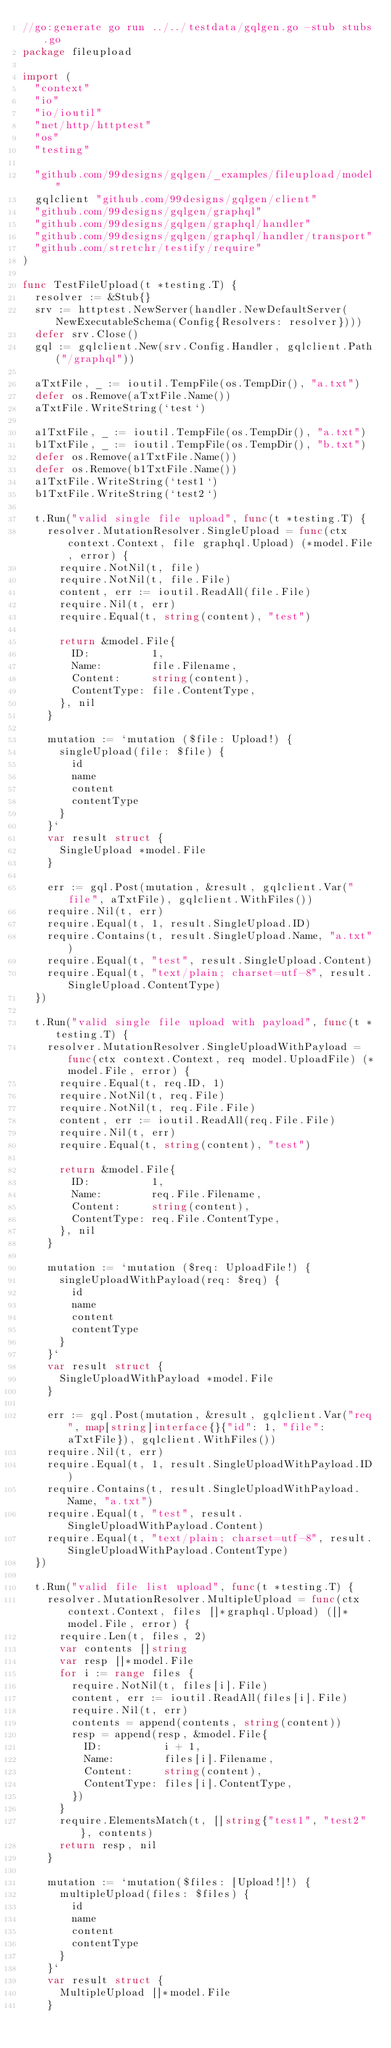<code> <loc_0><loc_0><loc_500><loc_500><_Go_>//go:generate go run ../../testdata/gqlgen.go -stub stubs.go
package fileupload

import (
	"context"
	"io"
	"io/ioutil"
	"net/http/httptest"
	"os"
	"testing"

	"github.com/99designs/gqlgen/_examples/fileupload/model"
	gqlclient "github.com/99designs/gqlgen/client"
	"github.com/99designs/gqlgen/graphql"
	"github.com/99designs/gqlgen/graphql/handler"
	"github.com/99designs/gqlgen/graphql/handler/transport"
	"github.com/stretchr/testify/require"
)

func TestFileUpload(t *testing.T) {
	resolver := &Stub{}
	srv := httptest.NewServer(handler.NewDefaultServer(NewExecutableSchema(Config{Resolvers: resolver})))
	defer srv.Close()
	gql := gqlclient.New(srv.Config.Handler, gqlclient.Path("/graphql"))

	aTxtFile, _ := ioutil.TempFile(os.TempDir(), "a.txt")
	defer os.Remove(aTxtFile.Name())
	aTxtFile.WriteString(`test`)

	a1TxtFile, _ := ioutil.TempFile(os.TempDir(), "a.txt")
	b1TxtFile, _ := ioutil.TempFile(os.TempDir(), "b.txt")
	defer os.Remove(a1TxtFile.Name())
	defer os.Remove(b1TxtFile.Name())
	a1TxtFile.WriteString(`test1`)
	b1TxtFile.WriteString(`test2`)

	t.Run("valid single file upload", func(t *testing.T) {
		resolver.MutationResolver.SingleUpload = func(ctx context.Context, file graphql.Upload) (*model.File, error) {
			require.NotNil(t, file)
			require.NotNil(t, file.File)
			content, err := ioutil.ReadAll(file.File)
			require.Nil(t, err)
			require.Equal(t, string(content), "test")

			return &model.File{
				ID:          1,
				Name:        file.Filename,
				Content:     string(content),
				ContentType: file.ContentType,
			}, nil
		}

		mutation := `mutation ($file: Upload!) {
			singleUpload(file: $file) {
				id
				name
				content
				contentType
			}
		}`
		var result struct {
			SingleUpload *model.File
		}

		err := gql.Post(mutation, &result, gqlclient.Var("file", aTxtFile), gqlclient.WithFiles())
		require.Nil(t, err)
		require.Equal(t, 1, result.SingleUpload.ID)
		require.Contains(t, result.SingleUpload.Name, "a.txt")
		require.Equal(t, "test", result.SingleUpload.Content)
		require.Equal(t, "text/plain; charset=utf-8", result.SingleUpload.ContentType)
	})

	t.Run("valid single file upload with payload", func(t *testing.T) {
		resolver.MutationResolver.SingleUploadWithPayload = func(ctx context.Context, req model.UploadFile) (*model.File, error) {
			require.Equal(t, req.ID, 1)
			require.NotNil(t, req.File)
			require.NotNil(t, req.File.File)
			content, err := ioutil.ReadAll(req.File.File)
			require.Nil(t, err)
			require.Equal(t, string(content), "test")

			return &model.File{
				ID:          1,
				Name:        req.File.Filename,
				Content:     string(content),
				ContentType: req.File.ContentType,
			}, nil
		}

		mutation := `mutation ($req: UploadFile!) {
			singleUploadWithPayload(req: $req) {
				id
				name
				content
				contentType
			}
		}`
		var result struct {
			SingleUploadWithPayload *model.File
		}

		err := gql.Post(mutation, &result, gqlclient.Var("req", map[string]interface{}{"id": 1, "file": aTxtFile}), gqlclient.WithFiles())
		require.Nil(t, err)
		require.Equal(t, 1, result.SingleUploadWithPayload.ID)
		require.Contains(t, result.SingleUploadWithPayload.Name, "a.txt")
		require.Equal(t, "test", result.SingleUploadWithPayload.Content)
		require.Equal(t, "text/plain; charset=utf-8", result.SingleUploadWithPayload.ContentType)
	})

	t.Run("valid file list upload", func(t *testing.T) {
		resolver.MutationResolver.MultipleUpload = func(ctx context.Context, files []*graphql.Upload) ([]*model.File, error) {
			require.Len(t, files, 2)
			var contents []string
			var resp []*model.File
			for i := range files {
				require.NotNil(t, files[i].File)
				content, err := ioutil.ReadAll(files[i].File)
				require.Nil(t, err)
				contents = append(contents, string(content))
				resp = append(resp, &model.File{
					ID:          i + 1,
					Name:        files[i].Filename,
					Content:     string(content),
					ContentType: files[i].ContentType,
				})
			}
			require.ElementsMatch(t, []string{"test1", "test2"}, contents)
			return resp, nil
		}

		mutation := `mutation($files: [Upload!]!) {
			multipleUpload(files: $files) {
				id
				name
				content
				contentType
			}
		}`
		var result struct {
			MultipleUpload []*model.File
		}
</code> 